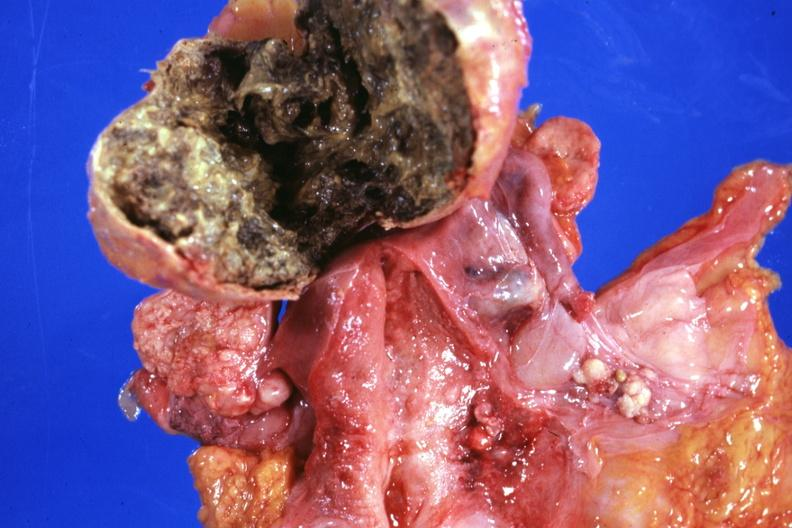what does this image show?
Answer the question using a single word or phrase. Opened lesion with necrotic center not too typical 